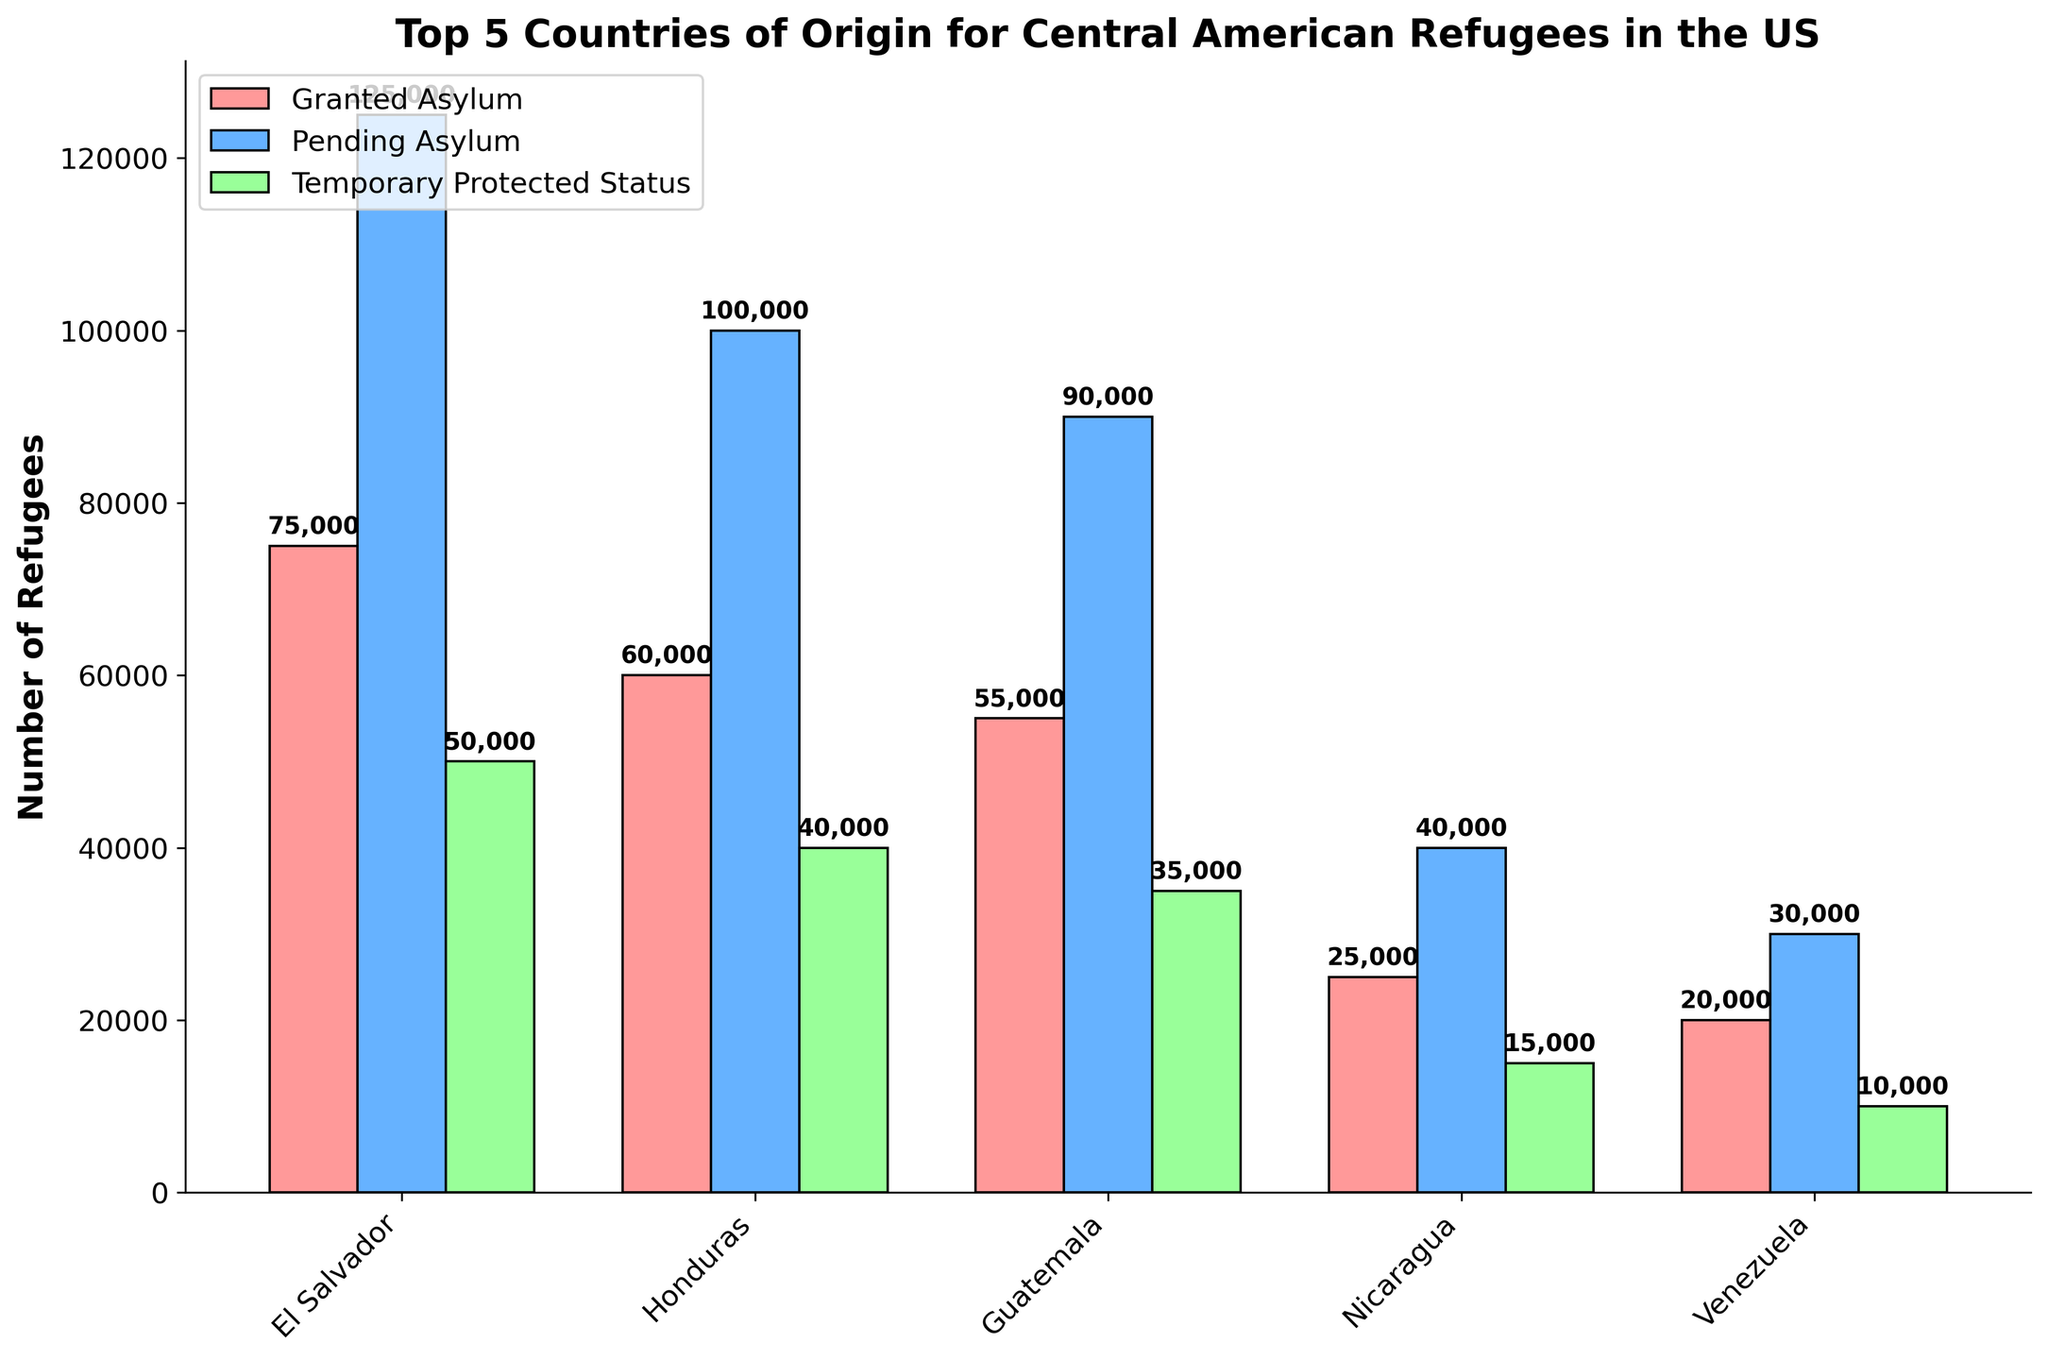Which country has the highest number of refugees with granted asylum? The country with the highest number of refugees with granted asylum can be determined by looking at the height of the red bars representing 'Granted Asylum'. El Salvador has the tallest red bar, indicating it has the highest number of refugees with granted asylum.
Answer: El Salvador Which country has the smallest number of refugees with temporary protected status? By observing the green bars representing 'Temporary Protected Status', the shortest green bar corresponds to Venezuela.
Answer: Venezuela What is the total number of refugees from Guatemala across all asylum statuses? Summing the numbers represented by the bars for Guatemala: 55,000 (Granted Asylum) + 90,000 (Pending Asylum) + 35,000 (Temporary Protected Status) = 180,000.
Answer: 180,000 Which country has more pending asylum cases, Honduras or Nicaragua? Comparing the heights of the blue bars for Honduras and Nicaragua, the blue bar for Honduras is taller, indicating more pending asylum cases.
Answer: Honduras How does the number of refugees with granted asylum in Venezuela compare to those in El Salvador? The height of the red bars for Venezuela and El Salvador can be compared. The red bar for El Salvador is significantly taller, indicating that El Salvador has more refugees with granted asylum compared to Venezuela.
Answer: El Salvador has more If we sum the numbers of pending asylum cases for Honduras and Nicaragua, what is the result? Adding the pending asylum numbers: 100,000 (Honduras) + 40,000 (Nicaragua) = 140,000.
Answer: 140,000 Which country has the second highest number of temporary protected status refugees? By comparing the heights of the green bars, the second tallest green bar after El Salvador belongs to Honduras.
Answer: Honduras How many more refugees from El Salvador are pending asylum compared to those from Guatemala? Subtracting the number of pending asylum cases for Guatemala from that for El Salvador: 125,000 (El Salvador) - 90,000 (Guatemala) = 35,000.
Answer: 35,000 What is the combined total of refugees with granted asylum for Honduras and Guatemala? Adding the granted asylum numbers for both countries: 60,000 (Honduras) + 55,000 (Guatemala) = 115,000.
Answer: 115,000 Which country has more total refugees, Nicaragua or Venezuela? Adding up the total numbers for both countries: Nicaragua: 25,000 (Granted Asylum) + 40,000 (Pending Asylum) + 15,000 (Temporary Protected Status) = 80,000; Venezuela: 20,000 (Granted Asylum) + 30,000 (Pending Asylum) + 10,000 (Temporary Protected Status) = 60,000; Since 80,000 > 60,000, Nicaragua has more total refugees.
Answer: Nicaragua 